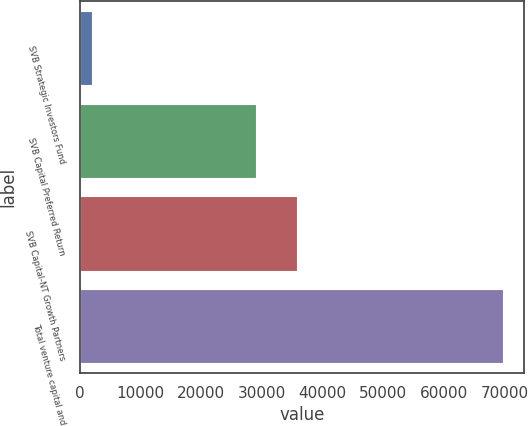Convert chart. <chart><loc_0><loc_0><loc_500><loc_500><bar_chart><fcel>SVB Strategic Investors Fund<fcel>SVB Capital Preferred Return<fcel>SVB Capital-NT Growth Partners<fcel>Total venture capital and<nl><fcel>2032<fcel>29089.6<fcel>35854<fcel>69676<nl></chart> 